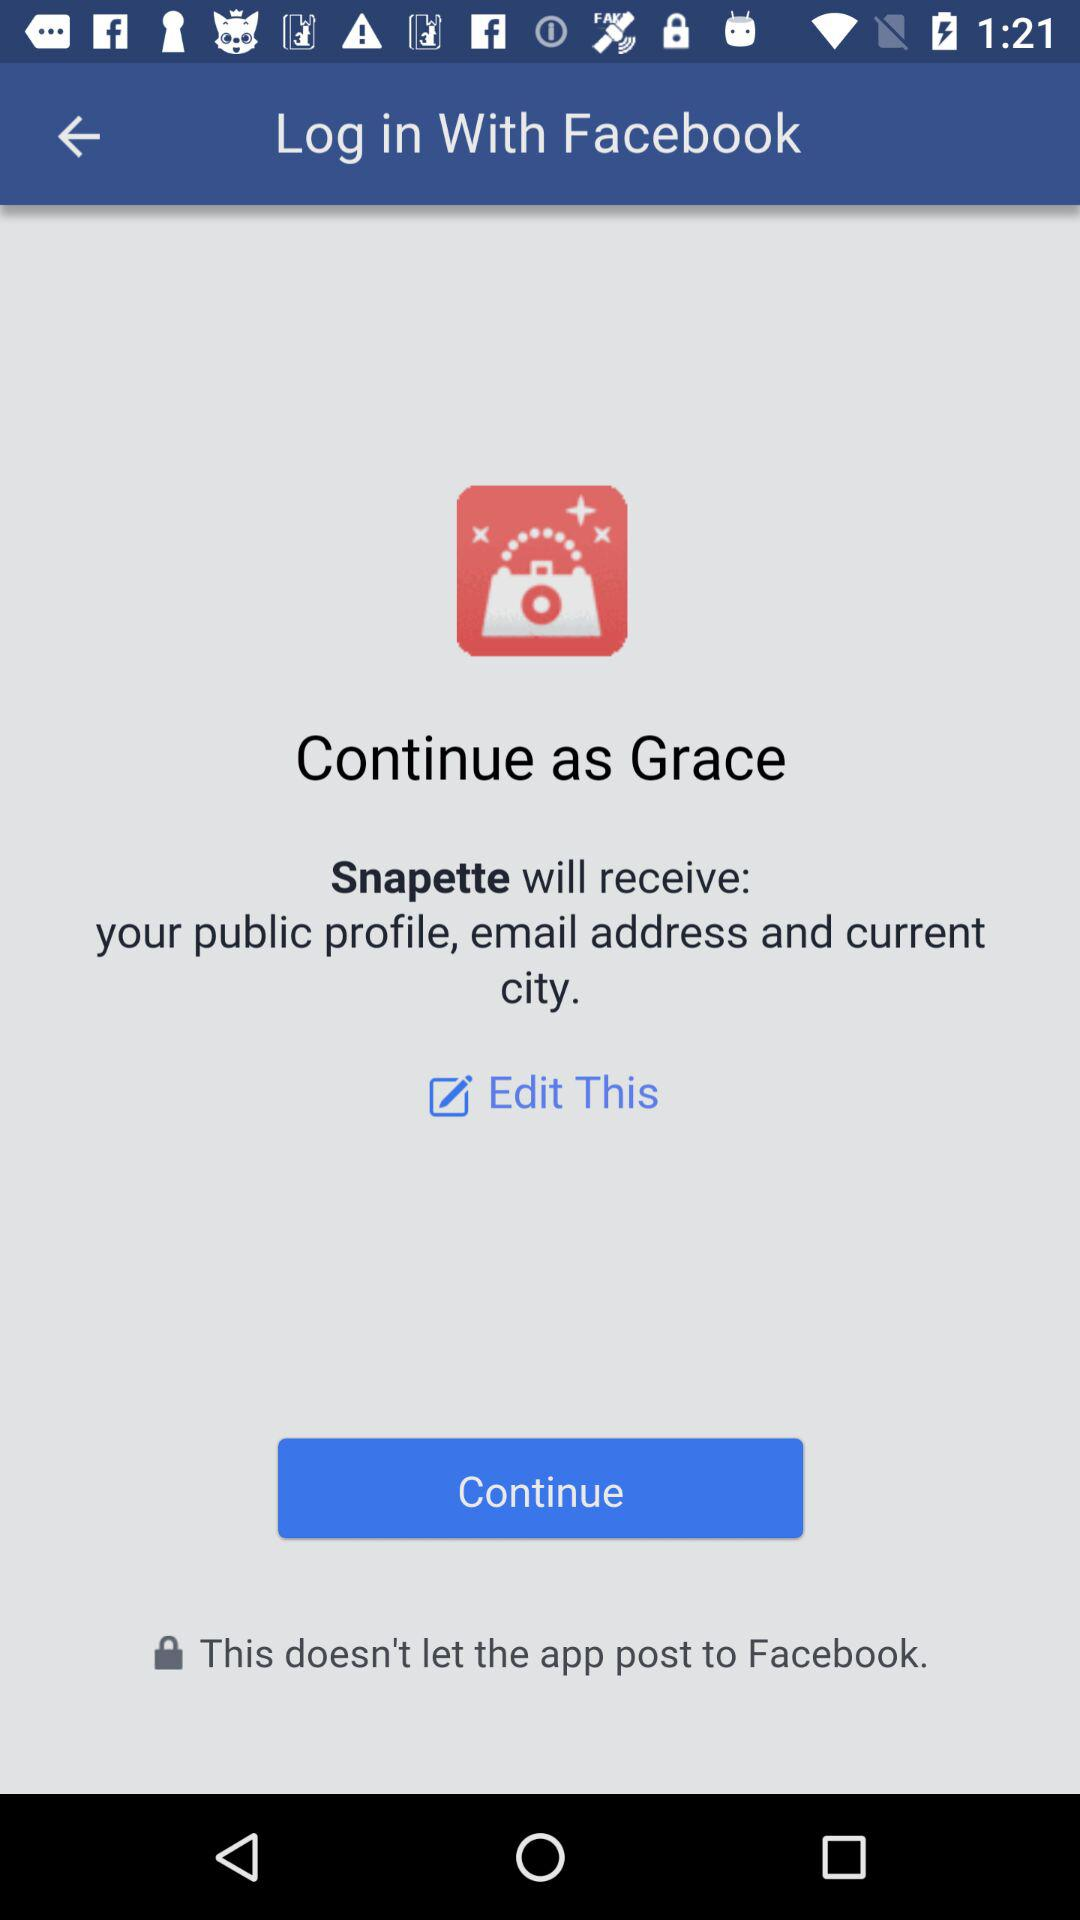Through what application did we log in? We log in with "Facebook". 